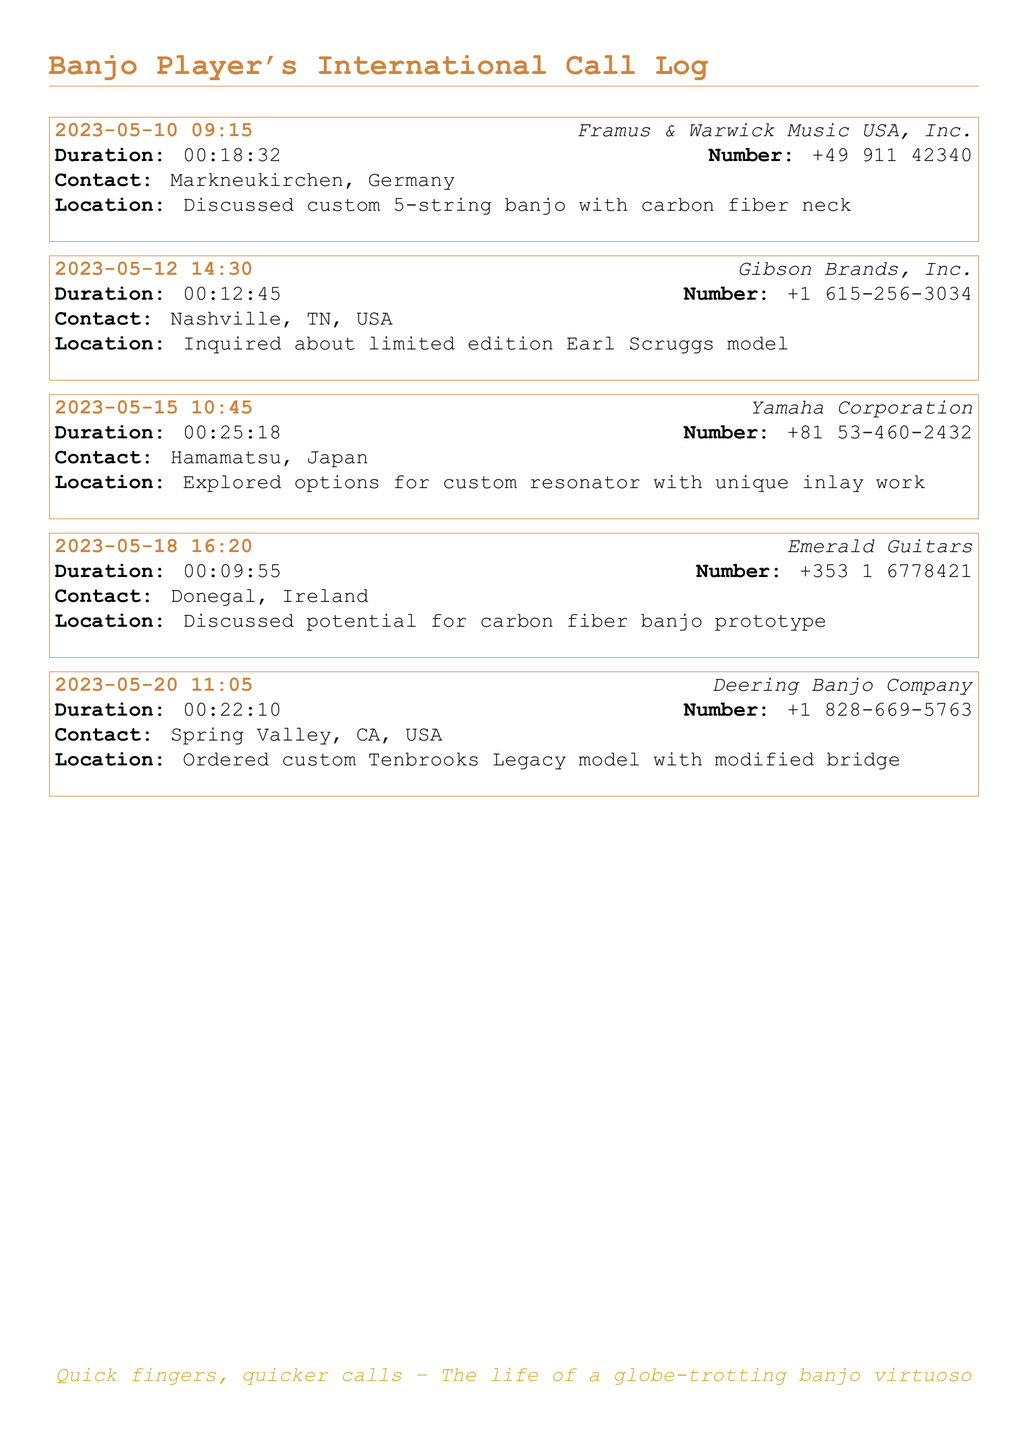what was the longest call duration? The longest call duration is the greatest value among all the call durations listed, which is 25 minutes and 18 seconds.
Answer: 00:25:18 who did the banjo player order a custom model from? The name of the company from which the custom model was ordered is specified in the call entry, which is Deering Banjo Company.
Answer: Deering Banjo Company how many calls were made to manufacturers in total? The total number of calls made to manufacturers is simply counted from the call log entries provided.
Answer: 5 which country was the call to Yamaha Corporation made in? The contact location for Yamaha Corporation is mentioned as Hamamatsu, Japan.
Answer: Japan what type of banjo model was discussed in the call with Framus & Warwick Music USA, Inc.? The specific type of banjo discussed in the call is indicated as a custom 5-string banjo.
Answer: custom 5-string banjo what was the purpose of the call to Emerald Guitars? The purpose of the call is summarized in the entry, indicating it was to discuss a carbon fiber banjo prototype.
Answer: carbon fiber banjo prototype which call had the shortest duration? The shortest call duration is identified by comparing the durations of all calls and is noted in the corresponding entry.
Answer: 00:09:55 who is mentioned in relation to the limited edition model? The name associated with the limited edition model is specifically mentioned in the call log entry referring to Earl Scruggs.
Answer: Earl Scruggs 